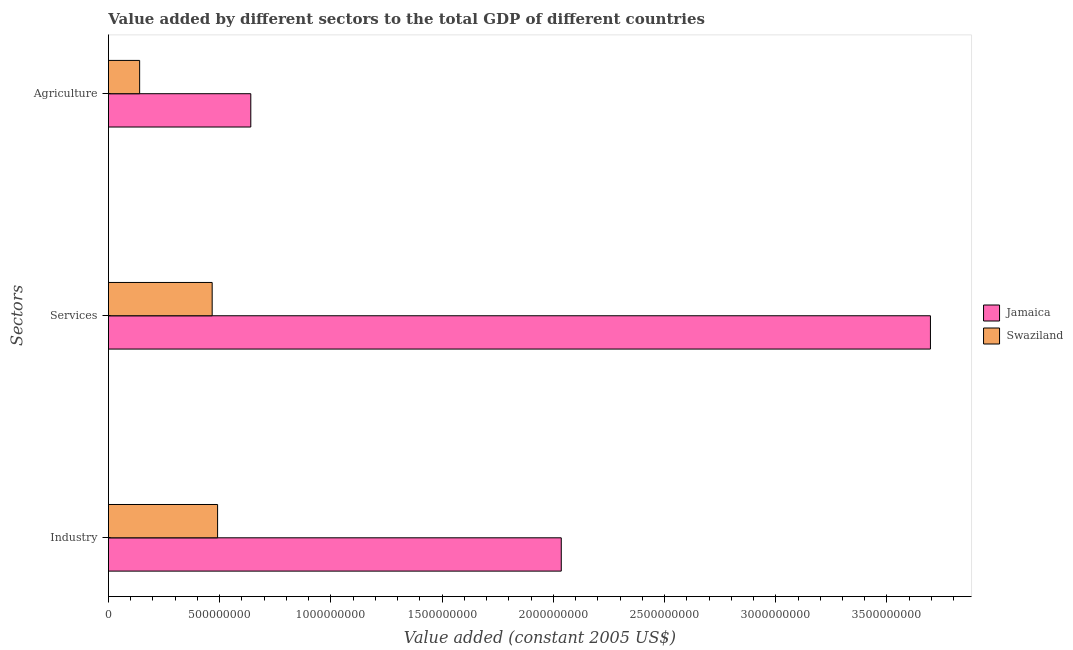How many different coloured bars are there?
Give a very brief answer. 2. Are the number of bars per tick equal to the number of legend labels?
Give a very brief answer. Yes. How many bars are there on the 1st tick from the top?
Your answer should be compact. 2. What is the label of the 2nd group of bars from the top?
Your answer should be very brief. Services. What is the value added by services in Jamaica?
Offer a very short reply. 3.70e+09. Across all countries, what is the maximum value added by industrial sector?
Keep it short and to the point. 2.04e+09. Across all countries, what is the minimum value added by services?
Give a very brief answer. 4.66e+08. In which country was the value added by agricultural sector maximum?
Ensure brevity in your answer.  Jamaica. In which country was the value added by industrial sector minimum?
Offer a very short reply. Swaziland. What is the total value added by industrial sector in the graph?
Offer a terse response. 2.53e+09. What is the difference between the value added by services in Jamaica and that in Swaziland?
Make the answer very short. 3.23e+09. What is the difference between the value added by industrial sector in Swaziland and the value added by services in Jamaica?
Keep it short and to the point. -3.20e+09. What is the average value added by agricultural sector per country?
Your answer should be compact. 3.90e+08. What is the difference between the value added by services and value added by agricultural sector in Swaziland?
Make the answer very short. 3.26e+08. What is the ratio of the value added by agricultural sector in Jamaica to that in Swaziland?
Your response must be concise. 4.56. What is the difference between the highest and the second highest value added by services?
Ensure brevity in your answer.  3.23e+09. What is the difference between the highest and the lowest value added by services?
Keep it short and to the point. 3.23e+09. What does the 2nd bar from the top in Agriculture represents?
Offer a terse response. Jamaica. What does the 2nd bar from the bottom in Agriculture represents?
Your answer should be very brief. Swaziland. How many bars are there?
Your answer should be compact. 6. Are all the bars in the graph horizontal?
Your response must be concise. Yes. Does the graph contain grids?
Make the answer very short. No. How many legend labels are there?
Your answer should be very brief. 2. How are the legend labels stacked?
Ensure brevity in your answer.  Vertical. What is the title of the graph?
Ensure brevity in your answer.  Value added by different sectors to the total GDP of different countries. Does "Aruba" appear as one of the legend labels in the graph?
Offer a very short reply. No. What is the label or title of the X-axis?
Provide a short and direct response. Value added (constant 2005 US$). What is the label or title of the Y-axis?
Make the answer very short. Sectors. What is the Value added (constant 2005 US$) of Jamaica in Industry?
Provide a succinct answer. 2.04e+09. What is the Value added (constant 2005 US$) of Swaziland in Industry?
Your answer should be compact. 4.91e+08. What is the Value added (constant 2005 US$) in Jamaica in Services?
Give a very brief answer. 3.70e+09. What is the Value added (constant 2005 US$) in Swaziland in Services?
Your response must be concise. 4.66e+08. What is the Value added (constant 2005 US$) of Jamaica in Agriculture?
Offer a terse response. 6.40e+08. What is the Value added (constant 2005 US$) of Swaziland in Agriculture?
Provide a succinct answer. 1.40e+08. Across all Sectors, what is the maximum Value added (constant 2005 US$) in Jamaica?
Your response must be concise. 3.70e+09. Across all Sectors, what is the maximum Value added (constant 2005 US$) in Swaziland?
Your response must be concise. 4.91e+08. Across all Sectors, what is the minimum Value added (constant 2005 US$) of Jamaica?
Offer a terse response. 6.40e+08. Across all Sectors, what is the minimum Value added (constant 2005 US$) in Swaziland?
Give a very brief answer. 1.40e+08. What is the total Value added (constant 2005 US$) in Jamaica in the graph?
Keep it short and to the point. 6.37e+09. What is the total Value added (constant 2005 US$) in Swaziland in the graph?
Your response must be concise. 1.10e+09. What is the difference between the Value added (constant 2005 US$) of Jamaica in Industry and that in Services?
Provide a succinct answer. -1.66e+09. What is the difference between the Value added (constant 2005 US$) in Swaziland in Industry and that in Services?
Provide a short and direct response. 2.44e+07. What is the difference between the Value added (constant 2005 US$) of Jamaica in Industry and that in Agriculture?
Offer a terse response. 1.40e+09. What is the difference between the Value added (constant 2005 US$) of Swaziland in Industry and that in Agriculture?
Your response must be concise. 3.50e+08. What is the difference between the Value added (constant 2005 US$) of Jamaica in Services and that in Agriculture?
Provide a short and direct response. 3.06e+09. What is the difference between the Value added (constant 2005 US$) in Swaziland in Services and that in Agriculture?
Ensure brevity in your answer.  3.26e+08. What is the difference between the Value added (constant 2005 US$) of Jamaica in Industry and the Value added (constant 2005 US$) of Swaziland in Services?
Offer a very short reply. 1.57e+09. What is the difference between the Value added (constant 2005 US$) in Jamaica in Industry and the Value added (constant 2005 US$) in Swaziland in Agriculture?
Give a very brief answer. 1.90e+09. What is the difference between the Value added (constant 2005 US$) in Jamaica in Services and the Value added (constant 2005 US$) in Swaziland in Agriculture?
Offer a terse response. 3.56e+09. What is the average Value added (constant 2005 US$) of Jamaica per Sectors?
Offer a very short reply. 2.12e+09. What is the average Value added (constant 2005 US$) of Swaziland per Sectors?
Ensure brevity in your answer.  3.66e+08. What is the difference between the Value added (constant 2005 US$) in Jamaica and Value added (constant 2005 US$) in Swaziland in Industry?
Your response must be concise. 1.55e+09. What is the difference between the Value added (constant 2005 US$) in Jamaica and Value added (constant 2005 US$) in Swaziland in Services?
Your answer should be very brief. 3.23e+09. What is the difference between the Value added (constant 2005 US$) of Jamaica and Value added (constant 2005 US$) of Swaziland in Agriculture?
Provide a succinct answer. 5.00e+08. What is the ratio of the Value added (constant 2005 US$) in Jamaica in Industry to that in Services?
Give a very brief answer. 0.55. What is the ratio of the Value added (constant 2005 US$) of Swaziland in Industry to that in Services?
Provide a short and direct response. 1.05. What is the ratio of the Value added (constant 2005 US$) in Jamaica in Industry to that in Agriculture?
Your answer should be very brief. 3.18. What is the ratio of the Value added (constant 2005 US$) in Swaziland in Industry to that in Agriculture?
Offer a terse response. 3.5. What is the ratio of the Value added (constant 2005 US$) in Jamaica in Services to that in Agriculture?
Your response must be concise. 5.77. What is the ratio of the Value added (constant 2005 US$) of Swaziland in Services to that in Agriculture?
Offer a very short reply. 3.32. What is the difference between the highest and the second highest Value added (constant 2005 US$) of Jamaica?
Offer a terse response. 1.66e+09. What is the difference between the highest and the second highest Value added (constant 2005 US$) of Swaziland?
Keep it short and to the point. 2.44e+07. What is the difference between the highest and the lowest Value added (constant 2005 US$) of Jamaica?
Offer a very short reply. 3.06e+09. What is the difference between the highest and the lowest Value added (constant 2005 US$) in Swaziland?
Your response must be concise. 3.50e+08. 